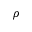<formula> <loc_0><loc_0><loc_500><loc_500>\rho</formula> 